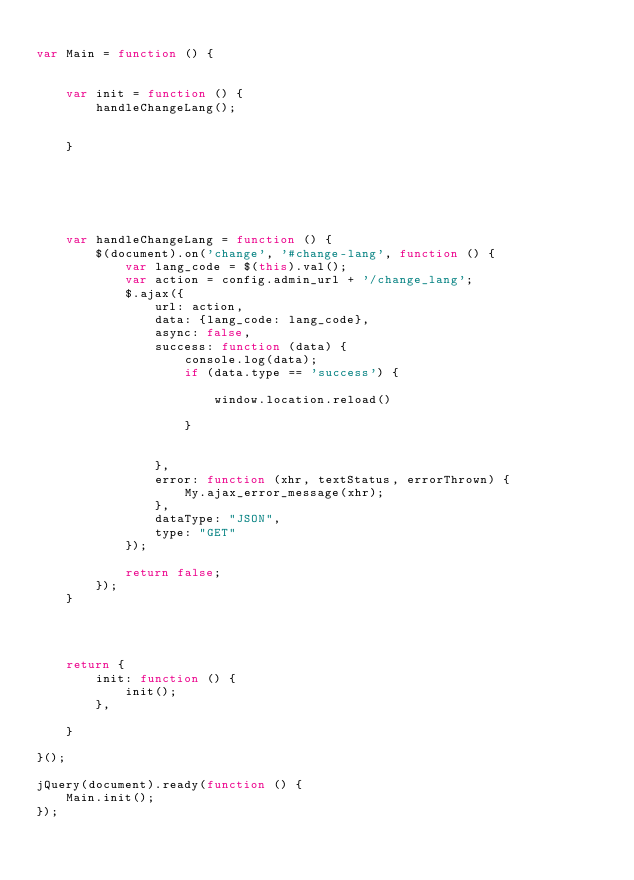<code> <loc_0><loc_0><loc_500><loc_500><_JavaScript_>
var Main = function () {


    var init = function () {
        handleChangeLang();
     

    }





    
    var handleChangeLang = function () {
        $(document).on('change', '#change-lang', function () {
            var lang_code = $(this).val();
            var action = config.admin_url + '/change_lang';
            $.ajax({
                url: action,
                data: {lang_code: lang_code},
                async: false,
                success: function (data) {
                    console.log(data);
                    if (data.type == 'success') {

                        window.location.reload()

                    }


                },
                error: function (xhr, textStatus, errorThrown) {
                    My.ajax_error_message(xhr);
                },
                dataType: "JSON",
                type: "GET"
            });

            return false;
        });
    }




    return {
        init: function () {
            init();
        },

    }

}();

jQuery(document).ready(function () {
    Main.init();
});


</code> 